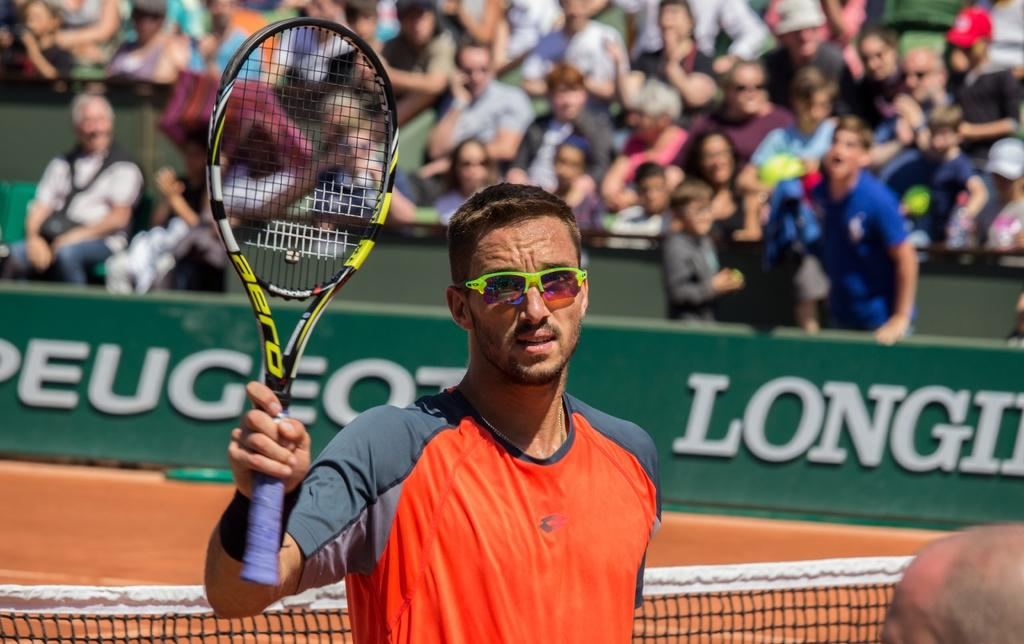How many people are in the image? There are two persons in the image. Where are the persons located? The persons are in a tennis court. What is one of the persons holding? One of the persons is holding a tennis racket. What separates the two sides of the tennis court? There is a tennis net in the image. Can you describe the presence of an audience in the image? There are people in the stands in the image. What type of book is the person reading in the image? There is no book or reading activity present in the image; the persons are engaged in a tennis match. Can you tell me how many prison bars are visible in the image? There are no prison bars present in the image; it is a tennis court setting. 